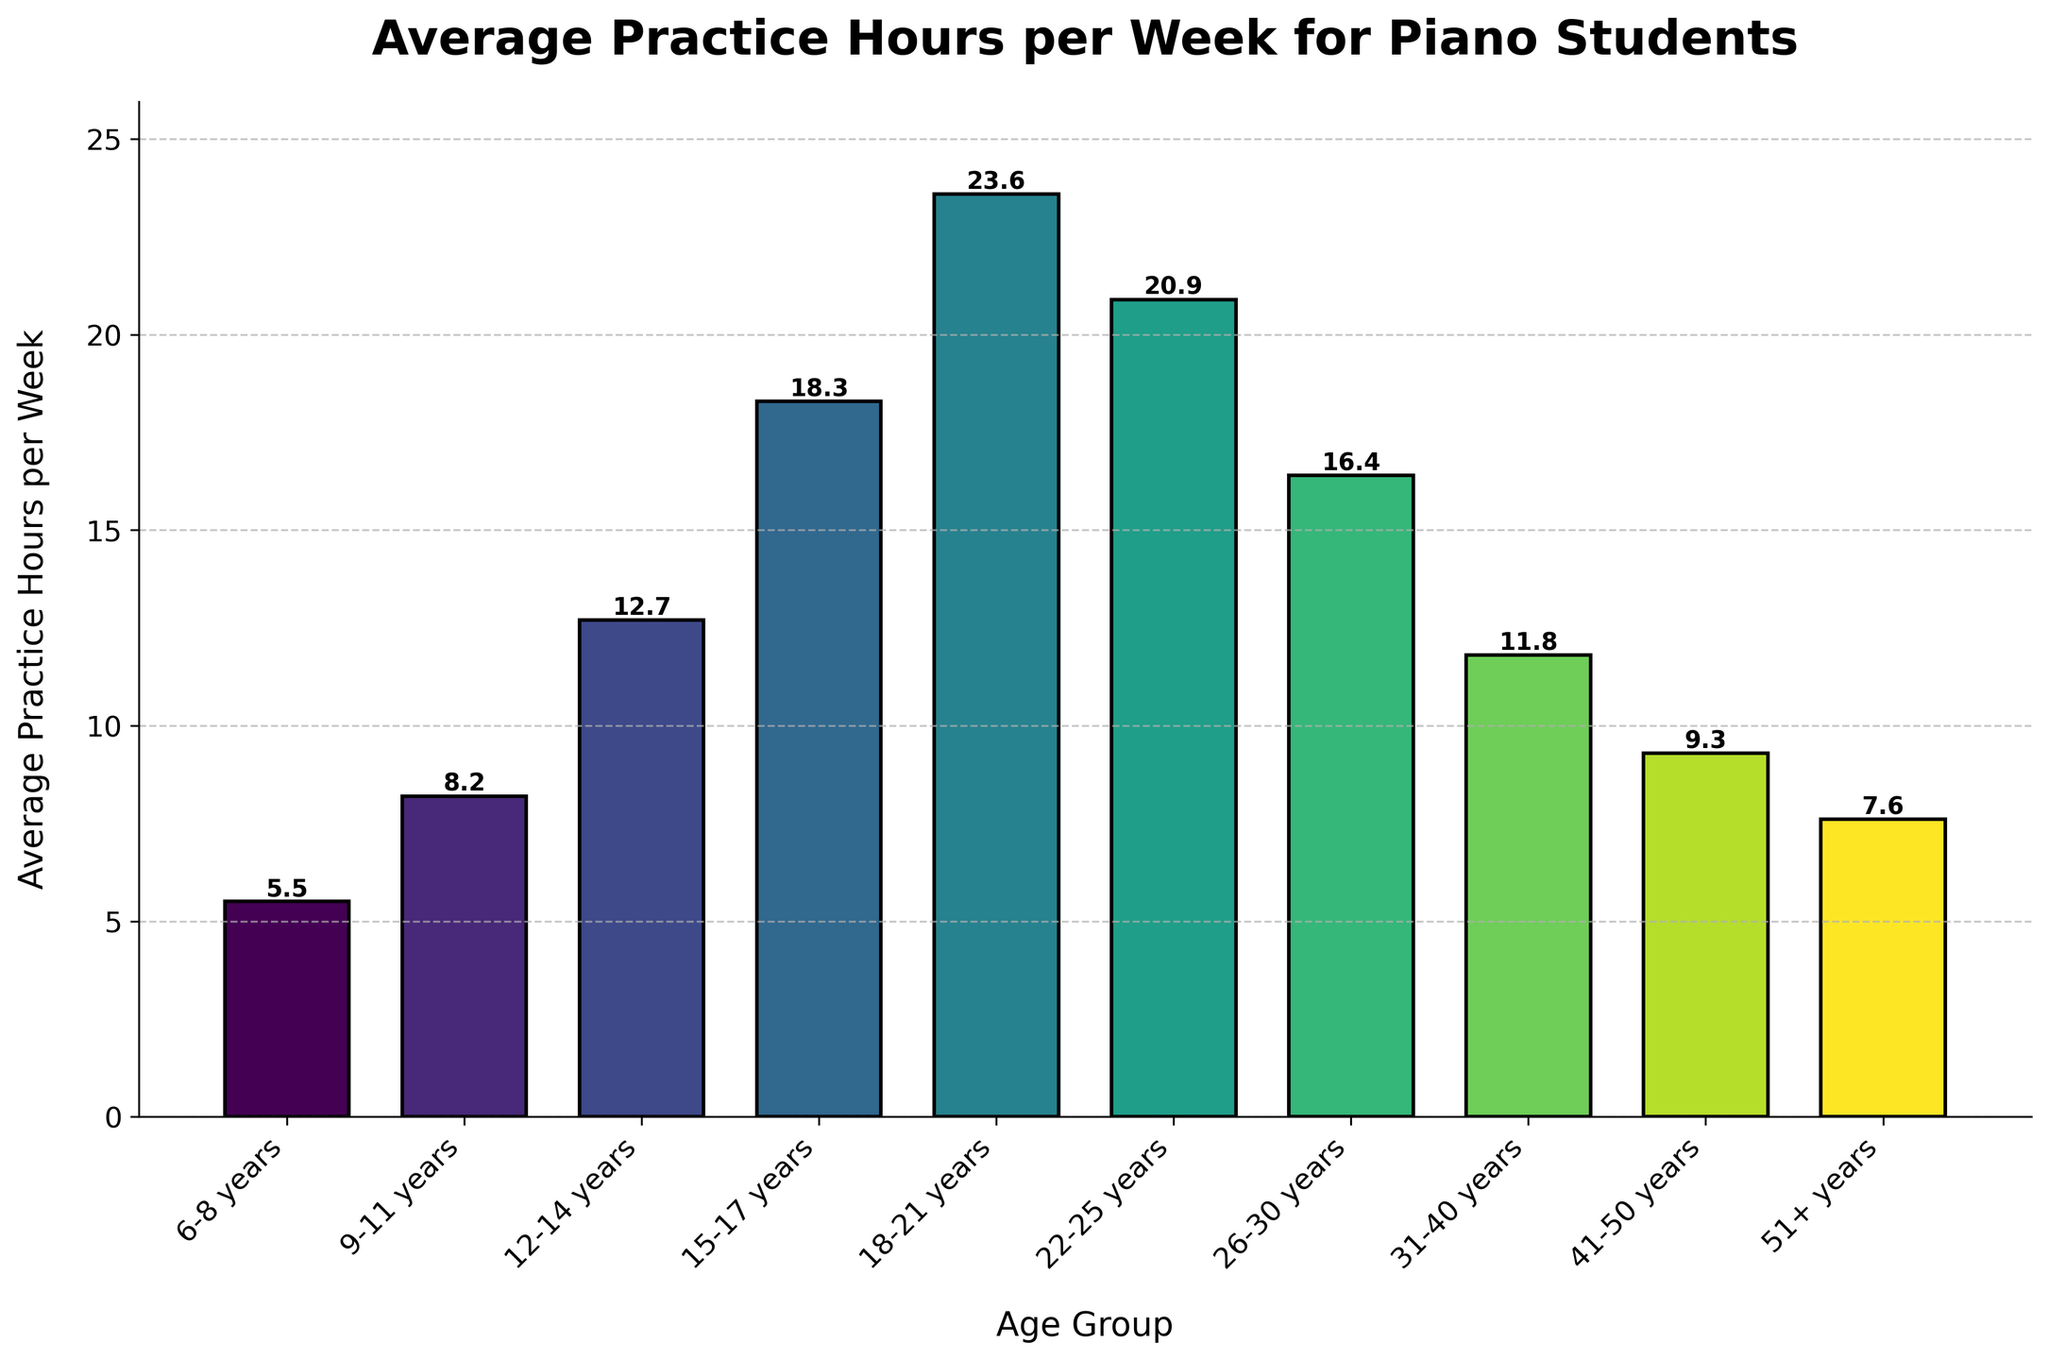What age group has the highest average practice hours per week? By looking at the height of the bars, the tallest bar represents the age group 18-21 years.
Answer: 18-21 years Which age group practices the most, 31-40 years or 22-25 years? Compare the height of the bars for the two age groups. The age group 22-25 years has a higher average practice time than the 31-40 years age group.
Answer: 22-25 years What is the difference in average practice hours per week between the age groups 15-17 years and 18-21 years? Subtract the average practice hours of the 15-17 years group (18.3) from the 18-21 years group (23.6). 23.6 - 18.3 = 5.3.
Answer: 5.3 Which age group practices more: 6-8 years, or 41-50 years? Compare the heights of the bars for the two age groups. The 6-8 years age group has a higher average practice time than the 41-50 years age group.
Answer: 6-8 years What's the average practice hours per week for all age groups combined? Sum the average practice hours for all age groups (5.5 + 8.2 + 12.7 + 18.3 + 23.6 + 20.9 + 16.4 + 11.8 + 9.3 + 7.6) = 134.3, then divide by the number of age groups (10). 134.3 / 10 = 13.43.
Answer: 13.4 Between which two consecutive age groups is the largest increase in average practice hours per week seen? Identify the differences between consecutive age groups and find the largest one: 8.2 - 5.5 = 2.7, 12.7 - 8.2 = 4.5, 18.3 - 12.7 = 5.6, 23.6 - 18.3 = 5.3, 20.9 - 23.6 = -2.7, 16.4 - 20.9 = -4.5, 11.8 - 16.4 = -4.6, 9.3 - 11.8 = -2.5, 7.6 - 9.3 = -1.7. The largest increase is between 15-17 and 18-21 years (5.6).
Answer: 15-17 and 18-21 years How many age groups have an average practice hours per week exceeding 10 hours? Look at each bar and count the ones with average practice hours greater than 10. There are 5 such age groups: 12-14, 15-17, 18-21, 22-25, and 26-30 years.
Answer: 5 What is the approximate total practice hours per week for the age groups 9-11 and 12-14 combined? Add the average practice hours for the 9-11 years (8.2) and the 12-14 years (12.7) groups. 8.2 + 12.7 = 20.9.
Answer: 20.9 